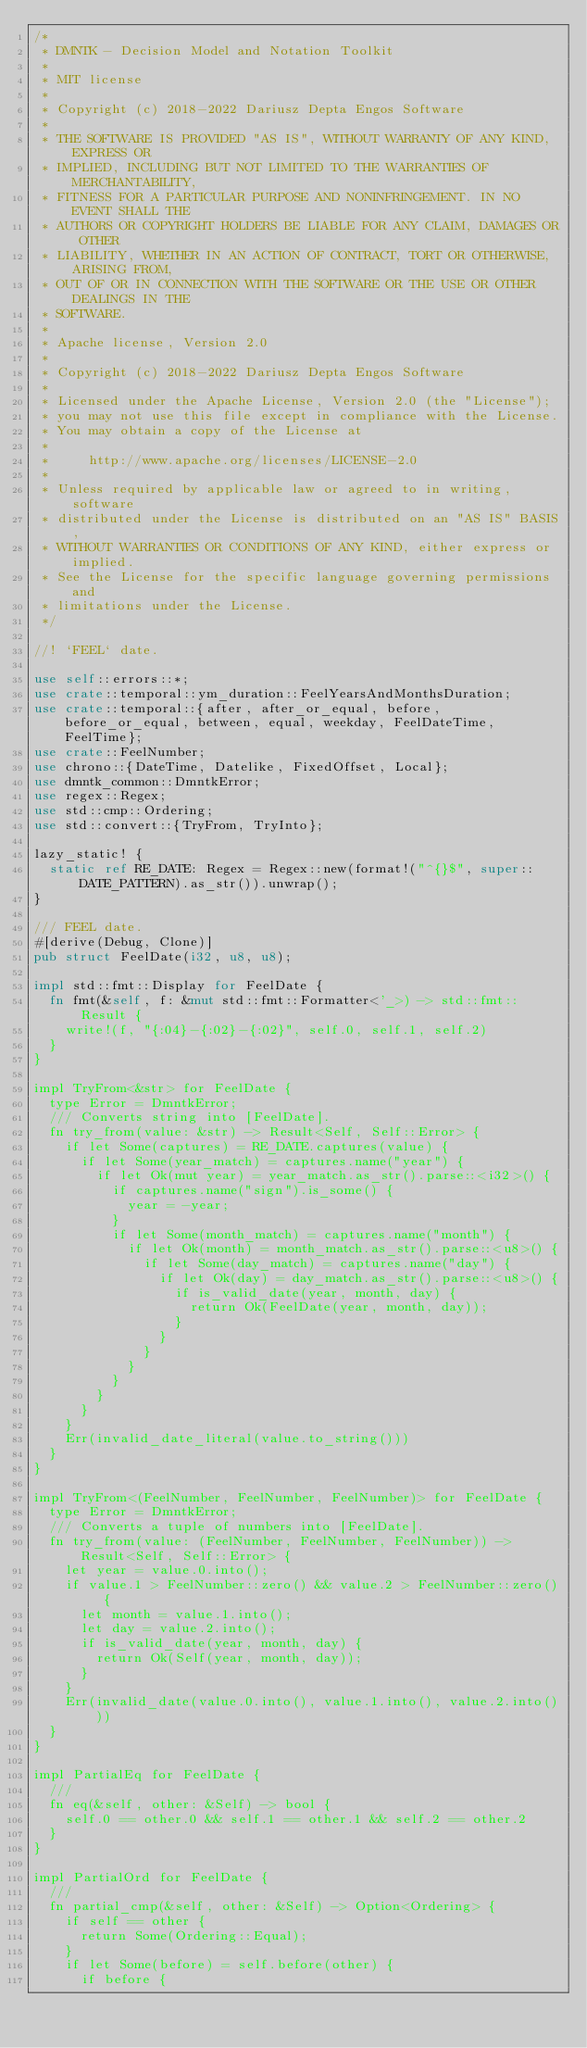Convert code to text. <code><loc_0><loc_0><loc_500><loc_500><_Rust_>/*
 * DMNTK - Decision Model and Notation Toolkit
 *
 * MIT license
 *
 * Copyright (c) 2018-2022 Dariusz Depta Engos Software
 *
 * THE SOFTWARE IS PROVIDED "AS IS", WITHOUT WARRANTY OF ANY KIND, EXPRESS OR
 * IMPLIED, INCLUDING BUT NOT LIMITED TO THE WARRANTIES OF MERCHANTABILITY,
 * FITNESS FOR A PARTICULAR PURPOSE AND NONINFRINGEMENT. IN NO EVENT SHALL THE
 * AUTHORS OR COPYRIGHT HOLDERS BE LIABLE FOR ANY CLAIM, DAMAGES OR OTHER
 * LIABILITY, WHETHER IN AN ACTION OF CONTRACT, TORT OR OTHERWISE, ARISING FROM,
 * OUT OF OR IN CONNECTION WITH THE SOFTWARE OR THE USE OR OTHER DEALINGS IN THE
 * SOFTWARE.
 *
 * Apache license, Version 2.0
 *
 * Copyright (c) 2018-2022 Dariusz Depta Engos Software
 *
 * Licensed under the Apache License, Version 2.0 (the "License");
 * you may not use this file except in compliance with the License.
 * You may obtain a copy of the License at
 *
 *     http://www.apache.org/licenses/LICENSE-2.0
 *
 * Unless required by applicable law or agreed to in writing, software
 * distributed under the License is distributed on an "AS IS" BASIS,
 * WITHOUT WARRANTIES OR CONDITIONS OF ANY KIND, either express or implied.
 * See the License for the specific language governing permissions and
 * limitations under the License.
 */

//! `FEEL` date.

use self::errors::*;
use crate::temporal::ym_duration::FeelYearsAndMonthsDuration;
use crate::temporal::{after, after_or_equal, before, before_or_equal, between, equal, weekday, FeelDateTime, FeelTime};
use crate::FeelNumber;
use chrono::{DateTime, Datelike, FixedOffset, Local};
use dmntk_common::DmntkError;
use regex::Regex;
use std::cmp::Ordering;
use std::convert::{TryFrom, TryInto};

lazy_static! {
  static ref RE_DATE: Regex = Regex::new(format!("^{}$", super::DATE_PATTERN).as_str()).unwrap();
}

/// FEEL date.
#[derive(Debug, Clone)]
pub struct FeelDate(i32, u8, u8);

impl std::fmt::Display for FeelDate {
  fn fmt(&self, f: &mut std::fmt::Formatter<'_>) -> std::fmt::Result {
    write!(f, "{:04}-{:02}-{:02}", self.0, self.1, self.2)
  }
}

impl TryFrom<&str> for FeelDate {
  type Error = DmntkError;
  /// Converts string into [FeelDate].
  fn try_from(value: &str) -> Result<Self, Self::Error> {
    if let Some(captures) = RE_DATE.captures(value) {
      if let Some(year_match) = captures.name("year") {
        if let Ok(mut year) = year_match.as_str().parse::<i32>() {
          if captures.name("sign").is_some() {
            year = -year;
          }
          if let Some(month_match) = captures.name("month") {
            if let Ok(month) = month_match.as_str().parse::<u8>() {
              if let Some(day_match) = captures.name("day") {
                if let Ok(day) = day_match.as_str().parse::<u8>() {
                  if is_valid_date(year, month, day) {
                    return Ok(FeelDate(year, month, day));
                  }
                }
              }
            }
          }
        }
      }
    }
    Err(invalid_date_literal(value.to_string()))
  }
}

impl TryFrom<(FeelNumber, FeelNumber, FeelNumber)> for FeelDate {
  type Error = DmntkError;
  /// Converts a tuple of numbers into [FeelDate].
  fn try_from(value: (FeelNumber, FeelNumber, FeelNumber)) -> Result<Self, Self::Error> {
    let year = value.0.into();
    if value.1 > FeelNumber::zero() && value.2 > FeelNumber::zero() {
      let month = value.1.into();
      let day = value.2.into();
      if is_valid_date(year, month, day) {
        return Ok(Self(year, month, day));
      }
    }
    Err(invalid_date(value.0.into(), value.1.into(), value.2.into()))
  }
}

impl PartialEq for FeelDate {
  ///
  fn eq(&self, other: &Self) -> bool {
    self.0 == other.0 && self.1 == other.1 && self.2 == other.2
  }
}

impl PartialOrd for FeelDate {
  ///
  fn partial_cmp(&self, other: &Self) -> Option<Ordering> {
    if self == other {
      return Some(Ordering::Equal);
    }
    if let Some(before) = self.before(other) {
      if before {</code> 